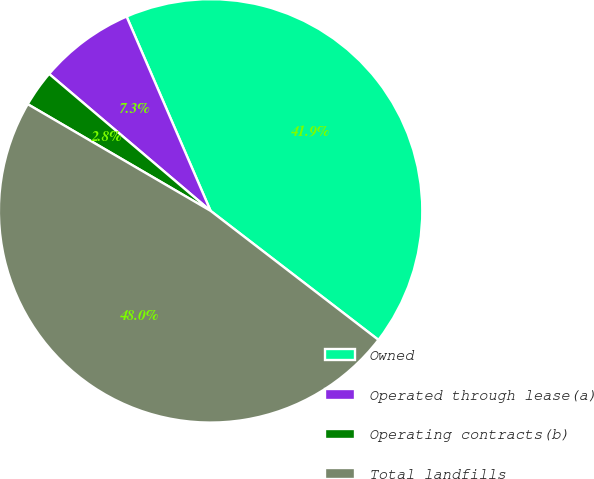Convert chart to OTSL. <chart><loc_0><loc_0><loc_500><loc_500><pie_chart><fcel>Owned<fcel>Operated through lease(a)<fcel>Operating contracts(b)<fcel>Total landfills<nl><fcel>41.92%<fcel>7.31%<fcel>2.79%<fcel>47.97%<nl></chart> 